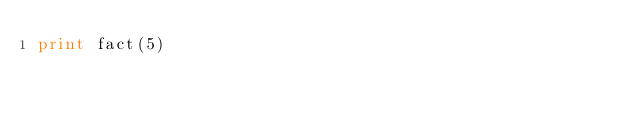<code> <loc_0><loc_0><loc_500><loc_500><_Python_>print fact(5)
</code> 